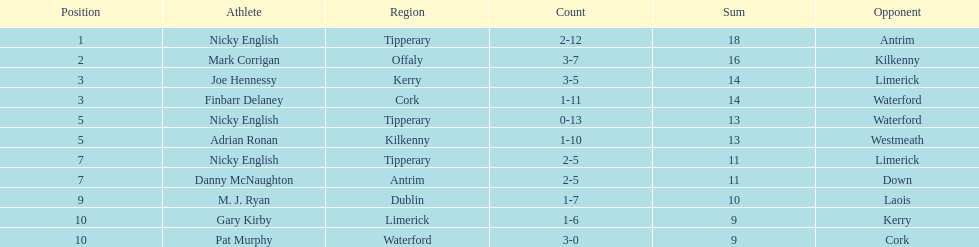Who ranked above mark corrigan? Nicky English. Could you parse the entire table as a dict? {'header': ['Position', 'Athlete', 'Region', 'Count', 'Sum', 'Opponent'], 'rows': [['1', 'Nicky English', 'Tipperary', '2-12', '18', 'Antrim'], ['2', 'Mark Corrigan', 'Offaly', '3-7', '16', 'Kilkenny'], ['3', 'Joe Hennessy', 'Kerry', '3-5', '14', 'Limerick'], ['3', 'Finbarr Delaney', 'Cork', '1-11', '14', 'Waterford'], ['5', 'Nicky English', 'Tipperary', '0-13', '13', 'Waterford'], ['5', 'Adrian Ronan', 'Kilkenny', '1-10', '13', 'Westmeath'], ['7', 'Nicky English', 'Tipperary', '2-5', '11', 'Limerick'], ['7', 'Danny McNaughton', 'Antrim', '2-5', '11', 'Down'], ['9', 'M. J. Ryan', 'Dublin', '1-7', '10', 'Laois'], ['10', 'Gary Kirby', 'Limerick', '1-6', '9', 'Kerry'], ['10', 'Pat Murphy', 'Waterford', '3-0', '9', 'Cork']]} 